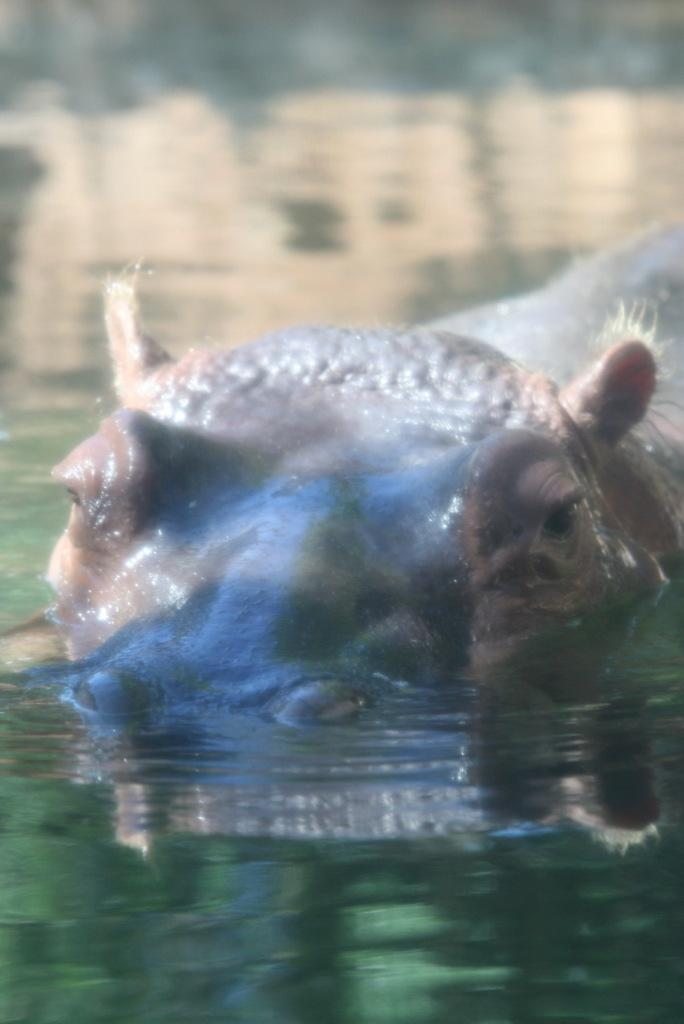What is the primary element visible in the image? There is water in the image. What type of animal can be seen in the water? There is a hippopotamus in the water. What type of bun is being used to feed the snake in the image? There is no bun or snake present in the image; it features water and a hippopotamus. 